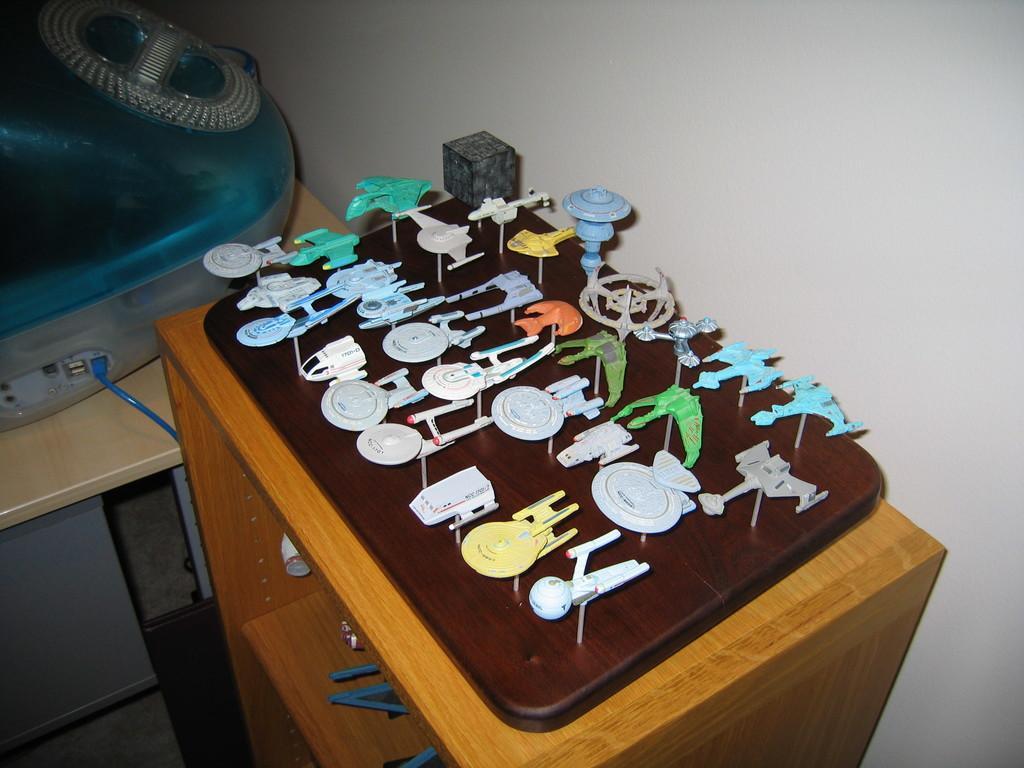Can you describe this image briefly? In this image at front there is a wooden table and on top of it there are some toys. Beside the wooden table there is another table and on top of it there is some object. On the backside there is a wall. 